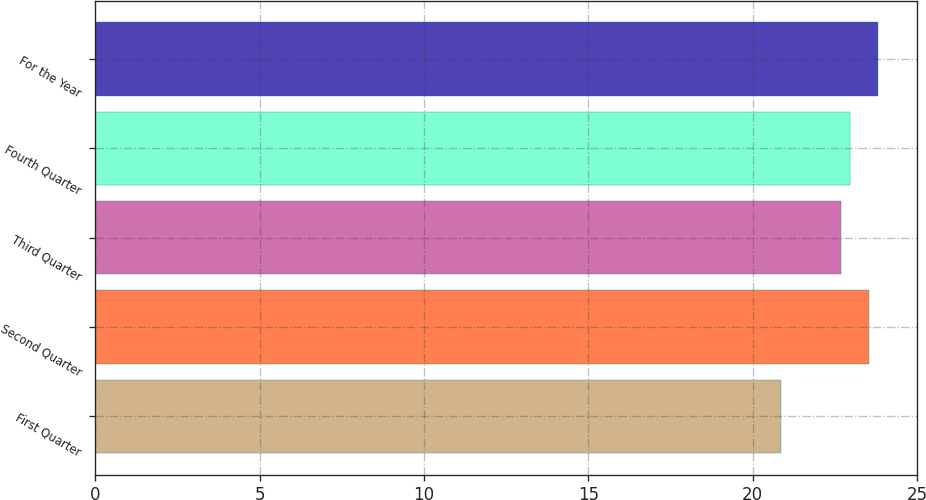Convert chart to OTSL. <chart><loc_0><loc_0><loc_500><loc_500><bar_chart><fcel>First Quarter<fcel>Second Quarter<fcel>Third Quarter<fcel>Fourth Quarter<fcel>For the Year<nl><fcel>20.85<fcel>23.54<fcel>22.68<fcel>22.95<fcel>23.81<nl></chart> 